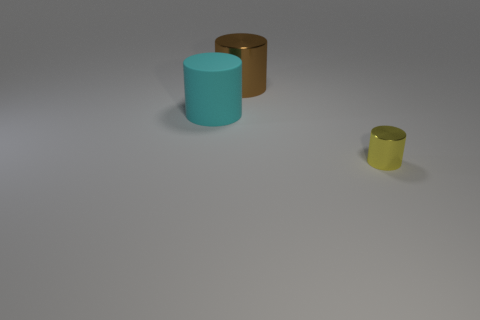What number of tiny objects are cyan rubber things or gray shiny things?
Keep it short and to the point. 0. What size is the other cyan matte thing that is the same shape as the small object?
Provide a short and direct response. Large. Is there any other thing that is the same size as the brown cylinder?
Give a very brief answer. Yes. There is a brown object that is to the right of the big cylinder in front of the big brown shiny cylinder; what is it made of?
Make the answer very short. Metal. How many metallic objects are small purple blocks or yellow cylinders?
Provide a succinct answer. 1. What color is the large shiny thing that is the same shape as the tiny metallic object?
Ensure brevity in your answer.  Brown. Is there a big cylinder that is left of the large cylinder in front of the large brown cylinder?
Offer a very short reply. No. What number of objects are left of the yellow metal thing and on the right side of the cyan cylinder?
Make the answer very short. 1. How many small yellow cylinders are the same material as the large cyan thing?
Provide a short and direct response. 0. What size is the thing in front of the large thing that is in front of the big metallic cylinder?
Provide a succinct answer. Small. 